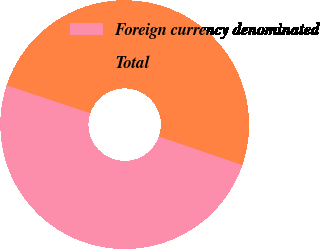<chart> <loc_0><loc_0><loc_500><loc_500><pie_chart><fcel>Foreign currency denominated<fcel>Total<nl><fcel>49.88%<fcel>50.12%<nl></chart> 